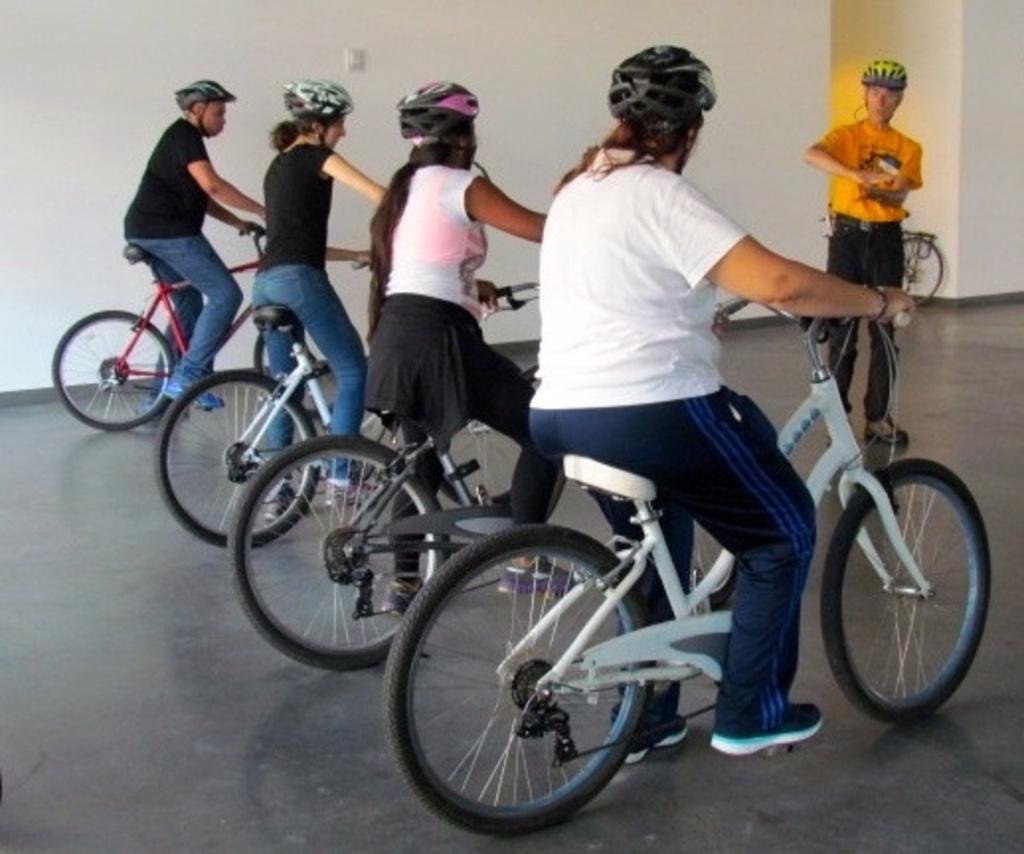How many people are in the image? There are four people in the image. What are the four people doing in the image? The four people are sitting on bicycles. Is there anyone else in the image besides the four people on bicycles? Yes, there is a person standing in front of the bicycles. What type of stocking is the person wearing on their play? There is no person wearing stockings or engaging in play in the image. 